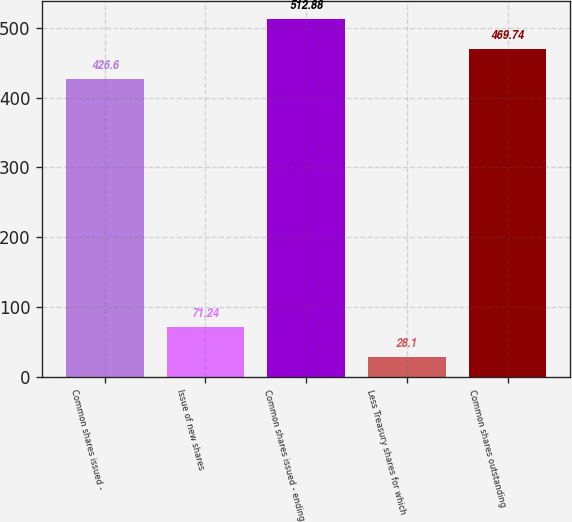Convert chart. <chart><loc_0><loc_0><loc_500><loc_500><bar_chart><fcel>Common shares issued -<fcel>Issue of new shares<fcel>Common shares issued - ending<fcel>Less Treasury shares for which<fcel>Common shares outstanding<nl><fcel>426.6<fcel>71.24<fcel>512.88<fcel>28.1<fcel>469.74<nl></chart> 